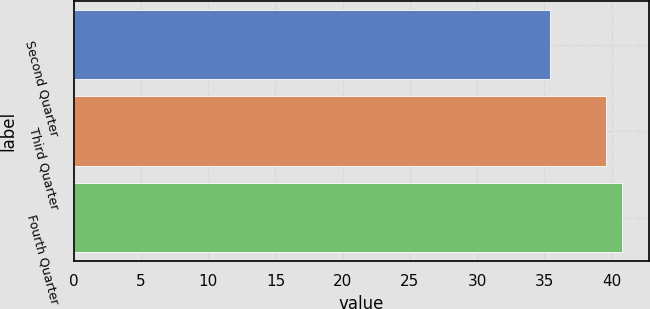<chart> <loc_0><loc_0><loc_500><loc_500><bar_chart><fcel>Second Quarter<fcel>Third Quarter<fcel>Fourth Quarter<nl><fcel>35.41<fcel>39.54<fcel>40.73<nl></chart> 